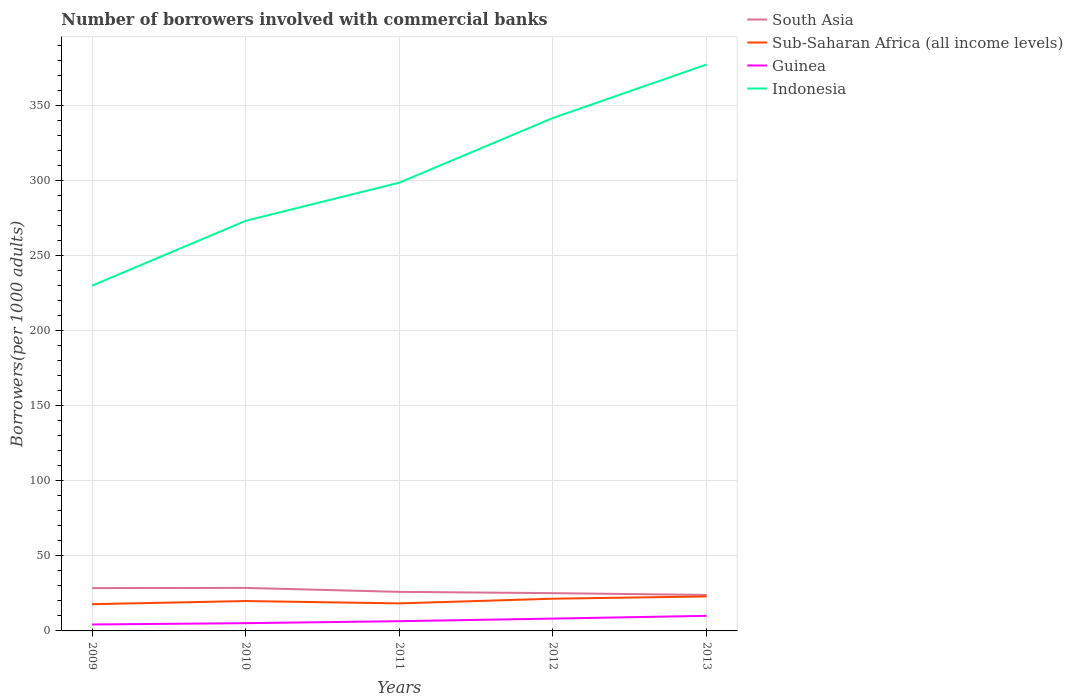How many different coloured lines are there?
Offer a terse response. 4. Does the line corresponding to Guinea intersect with the line corresponding to Sub-Saharan Africa (all income levels)?
Ensure brevity in your answer.  No. Across all years, what is the maximum number of borrowers involved with commercial banks in Guinea?
Your answer should be compact. 4.3. What is the total number of borrowers involved with commercial banks in Sub-Saharan Africa (all income levels) in the graph?
Offer a very short reply. -3.65. What is the difference between the highest and the second highest number of borrowers involved with commercial banks in Indonesia?
Offer a very short reply. 147.25. What is the difference between the highest and the lowest number of borrowers involved with commercial banks in South Asia?
Your response must be concise. 2. Is the number of borrowers involved with commercial banks in Guinea strictly greater than the number of borrowers involved with commercial banks in Sub-Saharan Africa (all income levels) over the years?
Provide a short and direct response. Yes. How many years are there in the graph?
Offer a very short reply. 5. What is the difference between two consecutive major ticks on the Y-axis?
Provide a short and direct response. 50. Does the graph contain grids?
Provide a succinct answer. Yes. How are the legend labels stacked?
Offer a terse response. Vertical. What is the title of the graph?
Offer a very short reply. Number of borrowers involved with commercial banks. Does "Lao PDR" appear as one of the legend labels in the graph?
Ensure brevity in your answer.  No. What is the label or title of the X-axis?
Offer a terse response. Years. What is the label or title of the Y-axis?
Make the answer very short. Borrowers(per 1000 adults). What is the Borrowers(per 1000 adults) of South Asia in 2009?
Provide a succinct answer. 28.52. What is the Borrowers(per 1000 adults) of Sub-Saharan Africa (all income levels) in 2009?
Keep it short and to the point. 17.81. What is the Borrowers(per 1000 adults) of Guinea in 2009?
Provide a succinct answer. 4.3. What is the Borrowers(per 1000 adults) in Indonesia in 2009?
Your answer should be very brief. 229.92. What is the Borrowers(per 1000 adults) in South Asia in 2010?
Provide a succinct answer. 28.64. What is the Borrowers(per 1000 adults) in Sub-Saharan Africa (all income levels) in 2010?
Your response must be concise. 19.9. What is the Borrowers(per 1000 adults) of Guinea in 2010?
Offer a very short reply. 5.16. What is the Borrowers(per 1000 adults) in Indonesia in 2010?
Offer a very short reply. 273.1. What is the Borrowers(per 1000 adults) in South Asia in 2011?
Your answer should be very brief. 26.01. What is the Borrowers(per 1000 adults) of Sub-Saharan Africa (all income levels) in 2011?
Make the answer very short. 18.33. What is the Borrowers(per 1000 adults) of Guinea in 2011?
Ensure brevity in your answer.  6.48. What is the Borrowers(per 1000 adults) of Indonesia in 2011?
Your answer should be compact. 298.51. What is the Borrowers(per 1000 adults) in South Asia in 2012?
Keep it short and to the point. 25.15. What is the Borrowers(per 1000 adults) in Sub-Saharan Africa (all income levels) in 2012?
Offer a very short reply. 21.46. What is the Borrowers(per 1000 adults) in Guinea in 2012?
Keep it short and to the point. 8.2. What is the Borrowers(per 1000 adults) in Indonesia in 2012?
Your answer should be compact. 341.57. What is the Borrowers(per 1000 adults) in South Asia in 2013?
Provide a succinct answer. 23.97. What is the Borrowers(per 1000 adults) of Sub-Saharan Africa (all income levels) in 2013?
Provide a short and direct response. 22.96. What is the Borrowers(per 1000 adults) in Guinea in 2013?
Ensure brevity in your answer.  10.05. What is the Borrowers(per 1000 adults) of Indonesia in 2013?
Your answer should be very brief. 377.16. Across all years, what is the maximum Borrowers(per 1000 adults) of South Asia?
Provide a succinct answer. 28.64. Across all years, what is the maximum Borrowers(per 1000 adults) of Sub-Saharan Africa (all income levels)?
Provide a short and direct response. 22.96. Across all years, what is the maximum Borrowers(per 1000 adults) of Guinea?
Offer a terse response. 10.05. Across all years, what is the maximum Borrowers(per 1000 adults) of Indonesia?
Ensure brevity in your answer.  377.16. Across all years, what is the minimum Borrowers(per 1000 adults) of South Asia?
Give a very brief answer. 23.97. Across all years, what is the minimum Borrowers(per 1000 adults) in Sub-Saharan Africa (all income levels)?
Your answer should be compact. 17.81. Across all years, what is the minimum Borrowers(per 1000 adults) of Guinea?
Provide a succinct answer. 4.3. Across all years, what is the minimum Borrowers(per 1000 adults) in Indonesia?
Provide a short and direct response. 229.92. What is the total Borrowers(per 1000 adults) of South Asia in the graph?
Give a very brief answer. 132.29. What is the total Borrowers(per 1000 adults) in Sub-Saharan Africa (all income levels) in the graph?
Provide a short and direct response. 100.46. What is the total Borrowers(per 1000 adults) in Guinea in the graph?
Your answer should be compact. 34.19. What is the total Borrowers(per 1000 adults) in Indonesia in the graph?
Give a very brief answer. 1520.25. What is the difference between the Borrowers(per 1000 adults) in South Asia in 2009 and that in 2010?
Give a very brief answer. -0.12. What is the difference between the Borrowers(per 1000 adults) in Sub-Saharan Africa (all income levels) in 2009 and that in 2010?
Provide a succinct answer. -2.1. What is the difference between the Borrowers(per 1000 adults) of Guinea in 2009 and that in 2010?
Keep it short and to the point. -0.87. What is the difference between the Borrowers(per 1000 adults) of Indonesia in 2009 and that in 2010?
Give a very brief answer. -43.19. What is the difference between the Borrowers(per 1000 adults) in South Asia in 2009 and that in 2011?
Provide a short and direct response. 2.51. What is the difference between the Borrowers(per 1000 adults) in Sub-Saharan Africa (all income levels) in 2009 and that in 2011?
Keep it short and to the point. -0.53. What is the difference between the Borrowers(per 1000 adults) in Guinea in 2009 and that in 2011?
Give a very brief answer. -2.19. What is the difference between the Borrowers(per 1000 adults) in Indonesia in 2009 and that in 2011?
Keep it short and to the point. -68.59. What is the difference between the Borrowers(per 1000 adults) of South Asia in 2009 and that in 2012?
Your answer should be very brief. 3.37. What is the difference between the Borrowers(per 1000 adults) in Sub-Saharan Africa (all income levels) in 2009 and that in 2012?
Keep it short and to the point. -3.65. What is the difference between the Borrowers(per 1000 adults) in Guinea in 2009 and that in 2012?
Your answer should be compact. -3.91. What is the difference between the Borrowers(per 1000 adults) of Indonesia in 2009 and that in 2012?
Your answer should be very brief. -111.65. What is the difference between the Borrowers(per 1000 adults) of South Asia in 2009 and that in 2013?
Ensure brevity in your answer.  4.55. What is the difference between the Borrowers(per 1000 adults) in Sub-Saharan Africa (all income levels) in 2009 and that in 2013?
Your answer should be compact. -5.16. What is the difference between the Borrowers(per 1000 adults) of Guinea in 2009 and that in 2013?
Your answer should be compact. -5.75. What is the difference between the Borrowers(per 1000 adults) in Indonesia in 2009 and that in 2013?
Provide a succinct answer. -147.25. What is the difference between the Borrowers(per 1000 adults) in South Asia in 2010 and that in 2011?
Provide a short and direct response. 2.63. What is the difference between the Borrowers(per 1000 adults) of Sub-Saharan Africa (all income levels) in 2010 and that in 2011?
Offer a very short reply. 1.57. What is the difference between the Borrowers(per 1000 adults) in Guinea in 2010 and that in 2011?
Your response must be concise. -1.32. What is the difference between the Borrowers(per 1000 adults) of Indonesia in 2010 and that in 2011?
Your answer should be very brief. -25.4. What is the difference between the Borrowers(per 1000 adults) in South Asia in 2010 and that in 2012?
Keep it short and to the point. 3.49. What is the difference between the Borrowers(per 1000 adults) in Sub-Saharan Africa (all income levels) in 2010 and that in 2012?
Keep it short and to the point. -1.56. What is the difference between the Borrowers(per 1000 adults) in Guinea in 2010 and that in 2012?
Make the answer very short. -3.04. What is the difference between the Borrowers(per 1000 adults) of Indonesia in 2010 and that in 2012?
Keep it short and to the point. -68.47. What is the difference between the Borrowers(per 1000 adults) of South Asia in 2010 and that in 2013?
Offer a very short reply. 4.68. What is the difference between the Borrowers(per 1000 adults) of Sub-Saharan Africa (all income levels) in 2010 and that in 2013?
Your response must be concise. -3.06. What is the difference between the Borrowers(per 1000 adults) of Guinea in 2010 and that in 2013?
Your answer should be compact. -4.88. What is the difference between the Borrowers(per 1000 adults) of Indonesia in 2010 and that in 2013?
Offer a very short reply. -104.06. What is the difference between the Borrowers(per 1000 adults) in South Asia in 2011 and that in 2012?
Provide a succinct answer. 0.86. What is the difference between the Borrowers(per 1000 adults) of Sub-Saharan Africa (all income levels) in 2011 and that in 2012?
Provide a succinct answer. -3.13. What is the difference between the Borrowers(per 1000 adults) of Guinea in 2011 and that in 2012?
Your answer should be compact. -1.72. What is the difference between the Borrowers(per 1000 adults) in Indonesia in 2011 and that in 2012?
Provide a short and direct response. -43.06. What is the difference between the Borrowers(per 1000 adults) in South Asia in 2011 and that in 2013?
Provide a succinct answer. 2.04. What is the difference between the Borrowers(per 1000 adults) of Sub-Saharan Africa (all income levels) in 2011 and that in 2013?
Your answer should be very brief. -4.63. What is the difference between the Borrowers(per 1000 adults) of Guinea in 2011 and that in 2013?
Keep it short and to the point. -3.56. What is the difference between the Borrowers(per 1000 adults) in Indonesia in 2011 and that in 2013?
Ensure brevity in your answer.  -78.66. What is the difference between the Borrowers(per 1000 adults) in South Asia in 2012 and that in 2013?
Ensure brevity in your answer.  1.18. What is the difference between the Borrowers(per 1000 adults) in Sub-Saharan Africa (all income levels) in 2012 and that in 2013?
Give a very brief answer. -1.5. What is the difference between the Borrowers(per 1000 adults) in Guinea in 2012 and that in 2013?
Ensure brevity in your answer.  -1.84. What is the difference between the Borrowers(per 1000 adults) in Indonesia in 2012 and that in 2013?
Your answer should be compact. -35.59. What is the difference between the Borrowers(per 1000 adults) in South Asia in 2009 and the Borrowers(per 1000 adults) in Sub-Saharan Africa (all income levels) in 2010?
Provide a short and direct response. 8.62. What is the difference between the Borrowers(per 1000 adults) in South Asia in 2009 and the Borrowers(per 1000 adults) in Guinea in 2010?
Provide a succinct answer. 23.36. What is the difference between the Borrowers(per 1000 adults) of South Asia in 2009 and the Borrowers(per 1000 adults) of Indonesia in 2010?
Offer a terse response. -244.58. What is the difference between the Borrowers(per 1000 adults) in Sub-Saharan Africa (all income levels) in 2009 and the Borrowers(per 1000 adults) in Guinea in 2010?
Offer a very short reply. 12.64. What is the difference between the Borrowers(per 1000 adults) in Sub-Saharan Africa (all income levels) in 2009 and the Borrowers(per 1000 adults) in Indonesia in 2010?
Make the answer very short. -255.3. What is the difference between the Borrowers(per 1000 adults) in Guinea in 2009 and the Borrowers(per 1000 adults) in Indonesia in 2010?
Ensure brevity in your answer.  -268.8. What is the difference between the Borrowers(per 1000 adults) in South Asia in 2009 and the Borrowers(per 1000 adults) in Sub-Saharan Africa (all income levels) in 2011?
Keep it short and to the point. 10.19. What is the difference between the Borrowers(per 1000 adults) in South Asia in 2009 and the Borrowers(per 1000 adults) in Guinea in 2011?
Keep it short and to the point. 22.04. What is the difference between the Borrowers(per 1000 adults) of South Asia in 2009 and the Borrowers(per 1000 adults) of Indonesia in 2011?
Make the answer very short. -269.99. What is the difference between the Borrowers(per 1000 adults) in Sub-Saharan Africa (all income levels) in 2009 and the Borrowers(per 1000 adults) in Guinea in 2011?
Provide a succinct answer. 11.32. What is the difference between the Borrowers(per 1000 adults) in Sub-Saharan Africa (all income levels) in 2009 and the Borrowers(per 1000 adults) in Indonesia in 2011?
Keep it short and to the point. -280.7. What is the difference between the Borrowers(per 1000 adults) in Guinea in 2009 and the Borrowers(per 1000 adults) in Indonesia in 2011?
Make the answer very short. -294.21. What is the difference between the Borrowers(per 1000 adults) of South Asia in 2009 and the Borrowers(per 1000 adults) of Sub-Saharan Africa (all income levels) in 2012?
Give a very brief answer. 7.06. What is the difference between the Borrowers(per 1000 adults) of South Asia in 2009 and the Borrowers(per 1000 adults) of Guinea in 2012?
Your response must be concise. 20.32. What is the difference between the Borrowers(per 1000 adults) in South Asia in 2009 and the Borrowers(per 1000 adults) in Indonesia in 2012?
Offer a very short reply. -313.05. What is the difference between the Borrowers(per 1000 adults) of Sub-Saharan Africa (all income levels) in 2009 and the Borrowers(per 1000 adults) of Guinea in 2012?
Give a very brief answer. 9.6. What is the difference between the Borrowers(per 1000 adults) in Sub-Saharan Africa (all income levels) in 2009 and the Borrowers(per 1000 adults) in Indonesia in 2012?
Provide a succinct answer. -323.76. What is the difference between the Borrowers(per 1000 adults) in Guinea in 2009 and the Borrowers(per 1000 adults) in Indonesia in 2012?
Keep it short and to the point. -337.27. What is the difference between the Borrowers(per 1000 adults) of South Asia in 2009 and the Borrowers(per 1000 adults) of Sub-Saharan Africa (all income levels) in 2013?
Your response must be concise. 5.56. What is the difference between the Borrowers(per 1000 adults) of South Asia in 2009 and the Borrowers(per 1000 adults) of Guinea in 2013?
Your response must be concise. 18.48. What is the difference between the Borrowers(per 1000 adults) of South Asia in 2009 and the Borrowers(per 1000 adults) of Indonesia in 2013?
Offer a terse response. -348.64. What is the difference between the Borrowers(per 1000 adults) in Sub-Saharan Africa (all income levels) in 2009 and the Borrowers(per 1000 adults) in Guinea in 2013?
Provide a succinct answer. 7.76. What is the difference between the Borrowers(per 1000 adults) of Sub-Saharan Africa (all income levels) in 2009 and the Borrowers(per 1000 adults) of Indonesia in 2013?
Your response must be concise. -359.36. What is the difference between the Borrowers(per 1000 adults) in Guinea in 2009 and the Borrowers(per 1000 adults) in Indonesia in 2013?
Offer a terse response. -372.87. What is the difference between the Borrowers(per 1000 adults) of South Asia in 2010 and the Borrowers(per 1000 adults) of Sub-Saharan Africa (all income levels) in 2011?
Your answer should be very brief. 10.31. What is the difference between the Borrowers(per 1000 adults) of South Asia in 2010 and the Borrowers(per 1000 adults) of Guinea in 2011?
Your answer should be compact. 22.16. What is the difference between the Borrowers(per 1000 adults) in South Asia in 2010 and the Borrowers(per 1000 adults) in Indonesia in 2011?
Your response must be concise. -269.86. What is the difference between the Borrowers(per 1000 adults) in Sub-Saharan Africa (all income levels) in 2010 and the Borrowers(per 1000 adults) in Guinea in 2011?
Your answer should be very brief. 13.42. What is the difference between the Borrowers(per 1000 adults) of Sub-Saharan Africa (all income levels) in 2010 and the Borrowers(per 1000 adults) of Indonesia in 2011?
Keep it short and to the point. -278.6. What is the difference between the Borrowers(per 1000 adults) in Guinea in 2010 and the Borrowers(per 1000 adults) in Indonesia in 2011?
Offer a very short reply. -293.34. What is the difference between the Borrowers(per 1000 adults) in South Asia in 2010 and the Borrowers(per 1000 adults) in Sub-Saharan Africa (all income levels) in 2012?
Ensure brevity in your answer.  7.18. What is the difference between the Borrowers(per 1000 adults) of South Asia in 2010 and the Borrowers(per 1000 adults) of Guinea in 2012?
Your answer should be compact. 20.44. What is the difference between the Borrowers(per 1000 adults) in South Asia in 2010 and the Borrowers(per 1000 adults) in Indonesia in 2012?
Keep it short and to the point. -312.93. What is the difference between the Borrowers(per 1000 adults) of Sub-Saharan Africa (all income levels) in 2010 and the Borrowers(per 1000 adults) of Guinea in 2012?
Your answer should be very brief. 11.7. What is the difference between the Borrowers(per 1000 adults) in Sub-Saharan Africa (all income levels) in 2010 and the Borrowers(per 1000 adults) in Indonesia in 2012?
Your answer should be very brief. -321.66. What is the difference between the Borrowers(per 1000 adults) of Guinea in 2010 and the Borrowers(per 1000 adults) of Indonesia in 2012?
Provide a short and direct response. -336.4. What is the difference between the Borrowers(per 1000 adults) in South Asia in 2010 and the Borrowers(per 1000 adults) in Sub-Saharan Africa (all income levels) in 2013?
Offer a very short reply. 5.68. What is the difference between the Borrowers(per 1000 adults) in South Asia in 2010 and the Borrowers(per 1000 adults) in Guinea in 2013?
Your answer should be compact. 18.6. What is the difference between the Borrowers(per 1000 adults) of South Asia in 2010 and the Borrowers(per 1000 adults) of Indonesia in 2013?
Your response must be concise. -348.52. What is the difference between the Borrowers(per 1000 adults) in Sub-Saharan Africa (all income levels) in 2010 and the Borrowers(per 1000 adults) in Guinea in 2013?
Offer a terse response. 9.86. What is the difference between the Borrowers(per 1000 adults) in Sub-Saharan Africa (all income levels) in 2010 and the Borrowers(per 1000 adults) in Indonesia in 2013?
Offer a terse response. -357.26. What is the difference between the Borrowers(per 1000 adults) of Guinea in 2010 and the Borrowers(per 1000 adults) of Indonesia in 2013?
Provide a short and direct response. -372. What is the difference between the Borrowers(per 1000 adults) in South Asia in 2011 and the Borrowers(per 1000 adults) in Sub-Saharan Africa (all income levels) in 2012?
Keep it short and to the point. 4.55. What is the difference between the Borrowers(per 1000 adults) of South Asia in 2011 and the Borrowers(per 1000 adults) of Guinea in 2012?
Provide a succinct answer. 17.8. What is the difference between the Borrowers(per 1000 adults) in South Asia in 2011 and the Borrowers(per 1000 adults) in Indonesia in 2012?
Ensure brevity in your answer.  -315.56. What is the difference between the Borrowers(per 1000 adults) of Sub-Saharan Africa (all income levels) in 2011 and the Borrowers(per 1000 adults) of Guinea in 2012?
Keep it short and to the point. 10.13. What is the difference between the Borrowers(per 1000 adults) of Sub-Saharan Africa (all income levels) in 2011 and the Borrowers(per 1000 adults) of Indonesia in 2012?
Keep it short and to the point. -323.24. What is the difference between the Borrowers(per 1000 adults) of Guinea in 2011 and the Borrowers(per 1000 adults) of Indonesia in 2012?
Keep it short and to the point. -335.08. What is the difference between the Borrowers(per 1000 adults) of South Asia in 2011 and the Borrowers(per 1000 adults) of Sub-Saharan Africa (all income levels) in 2013?
Offer a very short reply. 3.05. What is the difference between the Borrowers(per 1000 adults) in South Asia in 2011 and the Borrowers(per 1000 adults) in Guinea in 2013?
Keep it short and to the point. 15.96. What is the difference between the Borrowers(per 1000 adults) in South Asia in 2011 and the Borrowers(per 1000 adults) in Indonesia in 2013?
Provide a succinct answer. -351.15. What is the difference between the Borrowers(per 1000 adults) of Sub-Saharan Africa (all income levels) in 2011 and the Borrowers(per 1000 adults) of Guinea in 2013?
Your answer should be very brief. 8.29. What is the difference between the Borrowers(per 1000 adults) of Sub-Saharan Africa (all income levels) in 2011 and the Borrowers(per 1000 adults) of Indonesia in 2013?
Make the answer very short. -358.83. What is the difference between the Borrowers(per 1000 adults) in Guinea in 2011 and the Borrowers(per 1000 adults) in Indonesia in 2013?
Offer a terse response. -370.68. What is the difference between the Borrowers(per 1000 adults) of South Asia in 2012 and the Borrowers(per 1000 adults) of Sub-Saharan Africa (all income levels) in 2013?
Your answer should be very brief. 2.19. What is the difference between the Borrowers(per 1000 adults) in South Asia in 2012 and the Borrowers(per 1000 adults) in Guinea in 2013?
Give a very brief answer. 15.1. What is the difference between the Borrowers(per 1000 adults) in South Asia in 2012 and the Borrowers(per 1000 adults) in Indonesia in 2013?
Give a very brief answer. -352.01. What is the difference between the Borrowers(per 1000 adults) of Sub-Saharan Africa (all income levels) in 2012 and the Borrowers(per 1000 adults) of Guinea in 2013?
Offer a very short reply. 11.41. What is the difference between the Borrowers(per 1000 adults) in Sub-Saharan Africa (all income levels) in 2012 and the Borrowers(per 1000 adults) in Indonesia in 2013?
Your answer should be compact. -355.7. What is the difference between the Borrowers(per 1000 adults) in Guinea in 2012 and the Borrowers(per 1000 adults) in Indonesia in 2013?
Offer a terse response. -368.96. What is the average Borrowers(per 1000 adults) in South Asia per year?
Provide a short and direct response. 26.46. What is the average Borrowers(per 1000 adults) of Sub-Saharan Africa (all income levels) per year?
Ensure brevity in your answer.  20.09. What is the average Borrowers(per 1000 adults) of Guinea per year?
Your answer should be very brief. 6.84. What is the average Borrowers(per 1000 adults) in Indonesia per year?
Provide a short and direct response. 304.05. In the year 2009, what is the difference between the Borrowers(per 1000 adults) of South Asia and Borrowers(per 1000 adults) of Sub-Saharan Africa (all income levels)?
Your response must be concise. 10.72. In the year 2009, what is the difference between the Borrowers(per 1000 adults) of South Asia and Borrowers(per 1000 adults) of Guinea?
Keep it short and to the point. 24.22. In the year 2009, what is the difference between the Borrowers(per 1000 adults) of South Asia and Borrowers(per 1000 adults) of Indonesia?
Provide a succinct answer. -201.4. In the year 2009, what is the difference between the Borrowers(per 1000 adults) of Sub-Saharan Africa (all income levels) and Borrowers(per 1000 adults) of Guinea?
Offer a very short reply. 13.51. In the year 2009, what is the difference between the Borrowers(per 1000 adults) in Sub-Saharan Africa (all income levels) and Borrowers(per 1000 adults) in Indonesia?
Offer a terse response. -212.11. In the year 2009, what is the difference between the Borrowers(per 1000 adults) of Guinea and Borrowers(per 1000 adults) of Indonesia?
Make the answer very short. -225.62. In the year 2010, what is the difference between the Borrowers(per 1000 adults) of South Asia and Borrowers(per 1000 adults) of Sub-Saharan Africa (all income levels)?
Provide a succinct answer. 8.74. In the year 2010, what is the difference between the Borrowers(per 1000 adults) in South Asia and Borrowers(per 1000 adults) in Guinea?
Offer a terse response. 23.48. In the year 2010, what is the difference between the Borrowers(per 1000 adults) of South Asia and Borrowers(per 1000 adults) of Indonesia?
Make the answer very short. -244.46. In the year 2010, what is the difference between the Borrowers(per 1000 adults) of Sub-Saharan Africa (all income levels) and Borrowers(per 1000 adults) of Guinea?
Your answer should be compact. 14.74. In the year 2010, what is the difference between the Borrowers(per 1000 adults) of Sub-Saharan Africa (all income levels) and Borrowers(per 1000 adults) of Indonesia?
Offer a very short reply. -253.2. In the year 2010, what is the difference between the Borrowers(per 1000 adults) of Guinea and Borrowers(per 1000 adults) of Indonesia?
Offer a very short reply. -267.94. In the year 2011, what is the difference between the Borrowers(per 1000 adults) of South Asia and Borrowers(per 1000 adults) of Sub-Saharan Africa (all income levels)?
Make the answer very short. 7.68. In the year 2011, what is the difference between the Borrowers(per 1000 adults) in South Asia and Borrowers(per 1000 adults) in Guinea?
Your answer should be compact. 19.53. In the year 2011, what is the difference between the Borrowers(per 1000 adults) in South Asia and Borrowers(per 1000 adults) in Indonesia?
Your answer should be very brief. -272.5. In the year 2011, what is the difference between the Borrowers(per 1000 adults) of Sub-Saharan Africa (all income levels) and Borrowers(per 1000 adults) of Guinea?
Make the answer very short. 11.85. In the year 2011, what is the difference between the Borrowers(per 1000 adults) of Sub-Saharan Africa (all income levels) and Borrowers(per 1000 adults) of Indonesia?
Offer a very short reply. -280.17. In the year 2011, what is the difference between the Borrowers(per 1000 adults) of Guinea and Borrowers(per 1000 adults) of Indonesia?
Give a very brief answer. -292.02. In the year 2012, what is the difference between the Borrowers(per 1000 adults) of South Asia and Borrowers(per 1000 adults) of Sub-Saharan Africa (all income levels)?
Your answer should be very brief. 3.69. In the year 2012, what is the difference between the Borrowers(per 1000 adults) of South Asia and Borrowers(per 1000 adults) of Guinea?
Ensure brevity in your answer.  16.94. In the year 2012, what is the difference between the Borrowers(per 1000 adults) of South Asia and Borrowers(per 1000 adults) of Indonesia?
Offer a very short reply. -316.42. In the year 2012, what is the difference between the Borrowers(per 1000 adults) of Sub-Saharan Africa (all income levels) and Borrowers(per 1000 adults) of Guinea?
Provide a succinct answer. 13.25. In the year 2012, what is the difference between the Borrowers(per 1000 adults) in Sub-Saharan Africa (all income levels) and Borrowers(per 1000 adults) in Indonesia?
Offer a very short reply. -320.11. In the year 2012, what is the difference between the Borrowers(per 1000 adults) in Guinea and Borrowers(per 1000 adults) in Indonesia?
Ensure brevity in your answer.  -333.36. In the year 2013, what is the difference between the Borrowers(per 1000 adults) of South Asia and Borrowers(per 1000 adults) of Guinea?
Offer a very short reply. 13.92. In the year 2013, what is the difference between the Borrowers(per 1000 adults) in South Asia and Borrowers(per 1000 adults) in Indonesia?
Provide a short and direct response. -353.2. In the year 2013, what is the difference between the Borrowers(per 1000 adults) in Sub-Saharan Africa (all income levels) and Borrowers(per 1000 adults) in Guinea?
Ensure brevity in your answer.  12.92. In the year 2013, what is the difference between the Borrowers(per 1000 adults) in Sub-Saharan Africa (all income levels) and Borrowers(per 1000 adults) in Indonesia?
Your answer should be very brief. -354.2. In the year 2013, what is the difference between the Borrowers(per 1000 adults) in Guinea and Borrowers(per 1000 adults) in Indonesia?
Your answer should be compact. -367.12. What is the ratio of the Borrowers(per 1000 adults) of South Asia in 2009 to that in 2010?
Make the answer very short. 1. What is the ratio of the Borrowers(per 1000 adults) of Sub-Saharan Africa (all income levels) in 2009 to that in 2010?
Ensure brevity in your answer.  0.89. What is the ratio of the Borrowers(per 1000 adults) of Guinea in 2009 to that in 2010?
Keep it short and to the point. 0.83. What is the ratio of the Borrowers(per 1000 adults) in Indonesia in 2009 to that in 2010?
Your response must be concise. 0.84. What is the ratio of the Borrowers(per 1000 adults) of South Asia in 2009 to that in 2011?
Your answer should be very brief. 1.1. What is the ratio of the Borrowers(per 1000 adults) of Sub-Saharan Africa (all income levels) in 2009 to that in 2011?
Make the answer very short. 0.97. What is the ratio of the Borrowers(per 1000 adults) in Guinea in 2009 to that in 2011?
Ensure brevity in your answer.  0.66. What is the ratio of the Borrowers(per 1000 adults) of Indonesia in 2009 to that in 2011?
Ensure brevity in your answer.  0.77. What is the ratio of the Borrowers(per 1000 adults) in South Asia in 2009 to that in 2012?
Give a very brief answer. 1.13. What is the ratio of the Borrowers(per 1000 adults) of Sub-Saharan Africa (all income levels) in 2009 to that in 2012?
Your response must be concise. 0.83. What is the ratio of the Borrowers(per 1000 adults) in Guinea in 2009 to that in 2012?
Make the answer very short. 0.52. What is the ratio of the Borrowers(per 1000 adults) of Indonesia in 2009 to that in 2012?
Your response must be concise. 0.67. What is the ratio of the Borrowers(per 1000 adults) in South Asia in 2009 to that in 2013?
Ensure brevity in your answer.  1.19. What is the ratio of the Borrowers(per 1000 adults) in Sub-Saharan Africa (all income levels) in 2009 to that in 2013?
Keep it short and to the point. 0.78. What is the ratio of the Borrowers(per 1000 adults) of Guinea in 2009 to that in 2013?
Offer a very short reply. 0.43. What is the ratio of the Borrowers(per 1000 adults) of Indonesia in 2009 to that in 2013?
Your response must be concise. 0.61. What is the ratio of the Borrowers(per 1000 adults) of South Asia in 2010 to that in 2011?
Make the answer very short. 1.1. What is the ratio of the Borrowers(per 1000 adults) of Sub-Saharan Africa (all income levels) in 2010 to that in 2011?
Your response must be concise. 1.09. What is the ratio of the Borrowers(per 1000 adults) of Guinea in 2010 to that in 2011?
Your answer should be compact. 0.8. What is the ratio of the Borrowers(per 1000 adults) in Indonesia in 2010 to that in 2011?
Provide a short and direct response. 0.91. What is the ratio of the Borrowers(per 1000 adults) of South Asia in 2010 to that in 2012?
Provide a succinct answer. 1.14. What is the ratio of the Borrowers(per 1000 adults) of Sub-Saharan Africa (all income levels) in 2010 to that in 2012?
Provide a short and direct response. 0.93. What is the ratio of the Borrowers(per 1000 adults) in Guinea in 2010 to that in 2012?
Ensure brevity in your answer.  0.63. What is the ratio of the Borrowers(per 1000 adults) of Indonesia in 2010 to that in 2012?
Provide a short and direct response. 0.8. What is the ratio of the Borrowers(per 1000 adults) of South Asia in 2010 to that in 2013?
Make the answer very short. 1.2. What is the ratio of the Borrowers(per 1000 adults) in Sub-Saharan Africa (all income levels) in 2010 to that in 2013?
Offer a very short reply. 0.87. What is the ratio of the Borrowers(per 1000 adults) of Guinea in 2010 to that in 2013?
Your response must be concise. 0.51. What is the ratio of the Borrowers(per 1000 adults) in Indonesia in 2010 to that in 2013?
Offer a terse response. 0.72. What is the ratio of the Borrowers(per 1000 adults) of South Asia in 2011 to that in 2012?
Keep it short and to the point. 1.03. What is the ratio of the Borrowers(per 1000 adults) in Sub-Saharan Africa (all income levels) in 2011 to that in 2012?
Your answer should be compact. 0.85. What is the ratio of the Borrowers(per 1000 adults) in Guinea in 2011 to that in 2012?
Ensure brevity in your answer.  0.79. What is the ratio of the Borrowers(per 1000 adults) in Indonesia in 2011 to that in 2012?
Offer a very short reply. 0.87. What is the ratio of the Borrowers(per 1000 adults) in South Asia in 2011 to that in 2013?
Ensure brevity in your answer.  1.09. What is the ratio of the Borrowers(per 1000 adults) in Sub-Saharan Africa (all income levels) in 2011 to that in 2013?
Offer a very short reply. 0.8. What is the ratio of the Borrowers(per 1000 adults) in Guinea in 2011 to that in 2013?
Give a very brief answer. 0.65. What is the ratio of the Borrowers(per 1000 adults) of Indonesia in 2011 to that in 2013?
Ensure brevity in your answer.  0.79. What is the ratio of the Borrowers(per 1000 adults) in South Asia in 2012 to that in 2013?
Offer a very short reply. 1.05. What is the ratio of the Borrowers(per 1000 adults) of Sub-Saharan Africa (all income levels) in 2012 to that in 2013?
Offer a terse response. 0.93. What is the ratio of the Borrowers(per 1000 adults) of Guinea in 2012 to that in 2013?
Provide a succinct answer. 0.82. What is the ratio of the Borrowers(per 1000 adults) of Indonesia in 2012 to that in 2013?
Offer a terse response. 0.91. What is the difference between the highest and the second highest Borrowers(per 1000 adults) in South Asia?
Ensure brevity in your answer.  0.12. What is the difference between the highest and the second highest Borrowers(per 1000 adults) of Sub-Saharan Africa (all income levels)?
Your answer should be compact. 1.5. What is the difference between the highest and the second highest Borrowers(per 1000 adults) in Guinea?
Ensure brevity in your answer.  1.84. What is the difference between the highest and the second highest Borrowers(per 1000 adults) in Indonesia?
Your answer should be very brief. 35.59. What is the difference between the highest and the lowest Borrowers(per 1000 adults) in South Asia?
Keep it short and to the point. 4.68. What is the difference between the highest and the lowest Borrowers(per 1000 adults) of Sub-Saharan Africa (all income levels)?
Make the answer very short. 5.16. What is the difference between the highest and the lowest Borrowers(per 1000 adults) of Guinea?
Provide a succinct answer. 5.75. What is the difference between the highest and the lowest Borrowers(per 1000 adults) of Indonesia?
Your answer should be compact. 147.25. 